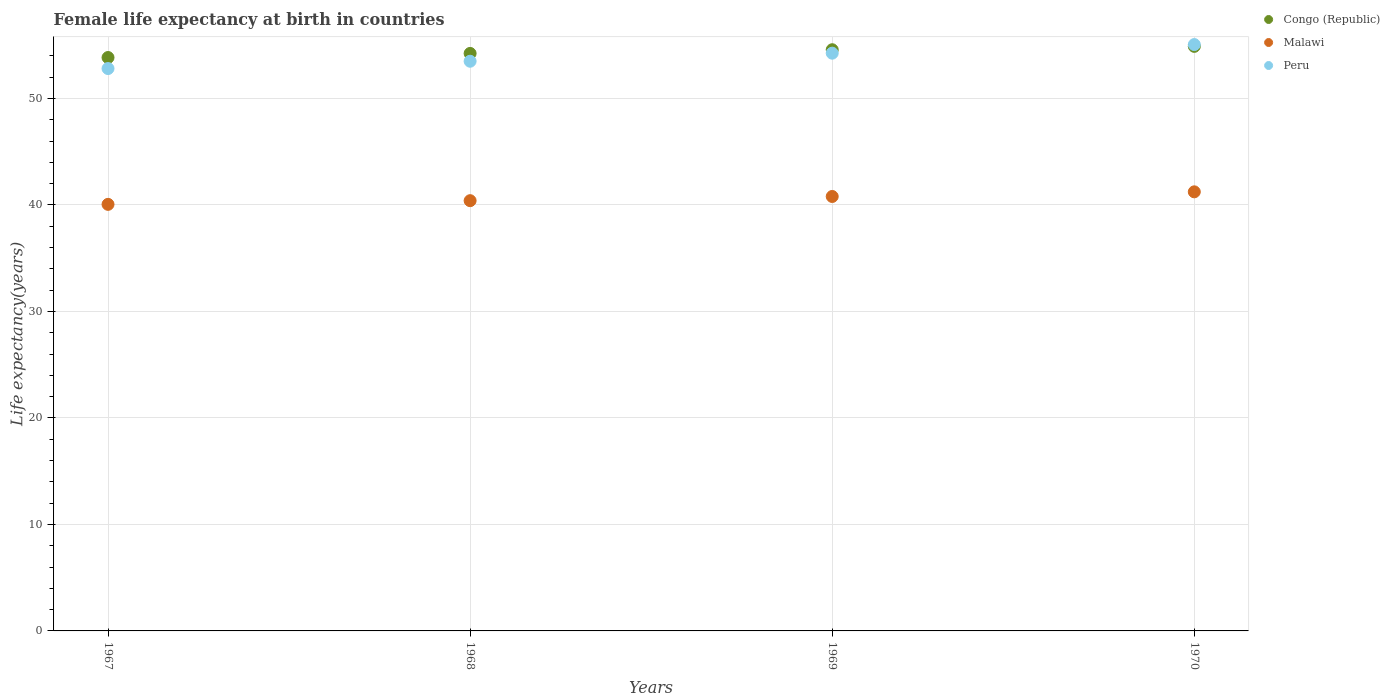What is the female life expectancy at birth in Congo (Republic) in 1969?
Provide a succinct answer. 54.58. Across all years, what is the maximum female life expectancy at birth in Congo (Republic)?
Offer a terse response. 54.89. Across all years, what is the minimum female life expectancy at birth in Peru?
Your answer should be very brief. 52.81. In which year was the female life expectancy at birth in Peru maximum?
Provide a short and direct response. 1970. In which year was the female life expectancy at birth in Congo (Republic) minimum?
Offer a terse response. 1967. What is the total female life expectancy at birth in Congo (Republic) in the graph?
Ensure brevity in your answer.  217.54. What is the difference between the female life expectancy at birth in Congo (Republic) in 1968 and that in 1969?
Provide a short and direct response. -0.35. What is the difference between the female life expectancy at birth in Malawi in 1969 and the female life expectancy at birth in Peru in 1970?
Your answer should be compact. -14.27. What is the average female life expectancy at birth in Malawi per year?
Your response must be concise. 40.62. In the year 1968, what is the difference between the female life expectancy at birth in Peru and female life expectancy at birth in Congo (Republic)?
Your answer should be very brief. -0.73. In how many years, is the female life expectancy at birth in Malawi greater than 42 years?
Provide a short and direct response. 0. What is the ratio of the female life expectancy at birth in Peru in 1969 to that in 1970?
Provide a succinct answer. 0.99. What is the difference between the highest and the second highest female life expectancy at birth in Malawi?
Keep it short and to the point. 0.44. What is the difference between the highest and the lowest female life expectancy at birth in Malawi?
Offer a terse response. 1.18. In how many years, is the female life expectancy at birth in Congo (Republic) greater than the average female life expectancy at birth in Congo (Republic) taken over all years?
Keep it short and to the point. 2. Does the female life expectancy at birth in Peru monotonically increase over the years?
Keep it short and to the point. Yes. Is the female life expectancy at birth in Malawi strictly less than the female life expectancy at birth in Congo (Republic) over the years?
Make the answer very short. Yes. What is the difference between two consecutive major ticks on the Y-axis?
Ensure brevity in your answer.  10. Does the graph contain any zero values?
Your response must be concise. No. Does the graph contain grids?
Keep it short and to the point. Yes. Where does the legend appear in the graph?
Offer a very short reply. Top right. How many legend labels are there?
Provide a short and direct response. 3. What is the title of the graph?
Your answer should be very brief. Female life expectancy at birth in countries. What is the label or title of the Y-axis?
Provide a succinct answer. Life expectancy(years). What is the Life expectancy(years) in Congo (Republic) in 1967?
Your answer should be very brief. 53.84. What is the Life expectancy(years) in Malawi in 1967?
Give a very brief answer. 40.05. What is the Life expectancy(years) in Peru in 1967?
Give a very brief answer. 52.81. What is the Life expectancy(years) in Congo (Republic) in 1968?
Make the answer very short. 54.23. What is the Life expectancy(years) of Malawi in 1968?
Offer a terse response. 40.4. What is the Life expectancy(years) of Peru in 1968?
Your answer should be very brief. 53.49. What is the Life expectancy(years) in Congo (Republic) in 1969?
Provide a short and direct response. 54.58. What is the Life expectancy(years) of Malawi in 1969?
Keep it short and to the point. 40.8. What is the Life expectancy(years) in Peru in 1969?
Provide a short and direct response. 54.25. What is the Life expectancy(years) of Congo (Republic) in 1970?
Offer a terse response. 54.89. What is the Life expectancy(years) in Malawi in 1970?
Provide a short and direct response. 41.23. What is the Life expectancy(years) in Peru in 1970?
Make the answer very short. 55.06. Across all years, what is the maximum Life expectancy(years) in Congo (Republic)?
Ensure brevity in your answer.  54.89. Across all years, what is the maximum Life expectancy(years) of Malawi?
Give a very brief answer. 41.23. Across all years, what is the maximum Life expectancy(years) of Peru?
Keep it short and to the point. 55.06. Across all years, what is the minimum Life expectancy(years) in Congo (Republic)?
Offer a very short reply. 53.84. Across all years, what is the minimum Life expectancy(years) of Malawi?
Offer a very short reply. 40.05. Across all years, what is the minimum Life expectancy(years) of Peru?
Ensure brevity in your answer.  52.81. What is the total Life expectancy(years) in Congo (Republic) in the graph?
Offer a very short reply. 217.54. What is the total Life expectancy(years) in Malawi in the graph?
Your answer should be very brief. 162.48. What is the total Life expectancy(years) of Peru in the graph?
Give a very brief answer. 215.61. What is the difference between the Life expectancy(years) of Congo (Republic) in 1967 and that in 1968?
Provide a short and direct response. -0.39. What is the difference between the Life expectancy(years) in Malawi in 1967 and that in 1968?
Provide a succinct answer. -0.35. What is the difference between the Life expectancy(years) in Peru in 1967 and that in 1968?
Your answer should be very brief. -0.69. What is the difference between the Life expectancy(years) in Congo (Republic) in 1967 and that in 1969?
Provide a short and direct response. -0.73. What is the difference between the Life expectancy(years) of Malawi in 1967 and that in 1969?
Offer a terse response. -0.74. What is the difference between the Life expectancy(years) in Peru in 1967 and that in 1969?
Offer a terse response. -1.44. What is the difference between the Life expectancy(years) of Congo (Republic) in 1967 and that in 1970?
Keep it short and to the point. -1.05. What is the difference between the Life expectancy(years) in Malawi in 1967 and that in 1970?
Keep it short and to the point. -1.18. What is the difference between the Life expectancy(years) of Peru in 1967 and that in 1970?
Your answer should be compact. -2.25. What is the difference between the Life expectancy(years) of Congo (Republic) in 1968 and that in 1969?
Your response must be concise. -0.35. What is the difference between the Life expectancy(years) in Malawi in 1968 and that in 1969?
Provide a succinct answer. -0.39. What is the difference between the Life expectancy(years) in Peru in 1968 and that in 1969?
Ensure brevity in your answer.  -0.76. What is the difference between the Life expectancy(years) in Congo (Republic) in 1968 and that in 1970?
Keep it short and to the point. -0.66. What is the difference between the Life expectancy(years) of Malawi in 1968 and that in 1970?
Offer a terse response. -0.83. What is the difference between the Life expectancy(years) of Peru in 1968 and that in 1970?
Keep it short and to the point. -1.57. What is the difference between the Life expectancy(years) in Congo (Republic) in 1969 and that in 1970?
Offer a terse response. -0.32. What is the difference between the Life expectancy(years) in Malawi in 1969 and that in 1970?
Provide a succinct answer. -0.44. What is the difference between the Life expectancy(years) of Peru in 1969 and that in 1970?
Keep it short and to the point. -0.81. What is the difference between the Life expectancy(years) of Congo (Republic) in 1967 and the Life expectancy(years) of Malawi in 1968?
Give a very brief answer. 13.44. What is the difference between the Life expectancy(years) of Congo (Republic) in 1967 and the Life expectancy(years) of Peru in 1968?
Offer a terse response. 0.35. What is the difference between the Life expectancy(years) of Malawi in 1967 and the Life expectancy(years) of Peru in 1968?
Offer a very short reply. -13.44. What is the difference between the Life expectancy(years) in Congo (Republic) in 1967 and the Life expectancy(years) in Malawi in 1969?
Your response must be concise. 13.05. What is the difference between the Life expectancy(years) in Congo (Republic) in 1967 and the Life expectancy(years) in Peru in 1969?
Provide a succinct answer. -0.41. What is the difference between the Life expectancy(years) of Malawi in 1967 and the Life expectancy(years) of Peru in 1969?
Ensure brevity in your answer.  -14.2. What is the difference between the Life expectancy(years) in Congo (Republic) in 1967 and the Life expectancy(years) in Malawi in 1970?
Ensure brevity in your answer.  12.61. What is the difference between the Life expectancy(years) of Congo (Republic) in 1967 and the Life expectancy(years) of Peru in 1970?
Provide a short and direct response. -1.22. What is the difference between the Life expectancy(years) in Malawi in 1967 and the Life expectancy(years) in Peru in 1970?
Offer a terse response. -15.01. What is the difference between the Life expectancy(years) in Congo (Republic) in 1968 and the Life expectancy(years) in Malawi in 1969?
Your answer should be compact. 13.43. What is the difference between the Life expectancy(years) of Congo (Republic) in 1968 and the Life expectancy(years) of Peru in 1969?
Provide a succinct answer. -0.02. What is the difference between the Life expectancy(years) of Malawi in 1968 and the Life expectancy(years) of Peru in 1969?
Your response must be concise. -13.85. What is the difference between the Life expectancy(years) of Congo (Republic) in 1968 and the Life expectancy(years) of Malawi in 1970?
Make the answer very short. 13. What is the difference between the Life expectancy(years) in Congo (Republic) in 1968 and the Life expectancy(years) in Peru in 1970?
Offer a very short reply. -0.83. What is the difference between the Life expectancy(years) of Malawi in 1968 and the Life expectancy(years) of Peru in 1970?
Offer a very short reply. -14.66. What is the difference between the Life expectancy(years) in Congo (Republic) in 1969 and the Life expectancy(years) in Malawi in 1970?
Keep it short and to the point. 13.34. What is the difference between the Life expectancy(years) in Congo (Republic) in 1969 and the Life expectancy(years) in Peru in 1970?
Your answer should be very brief. -0.48. What is the difference between the Life expectancy(years) in Malawi in 1969 and the Life expectancy(years) in Peru in 1970?
Provide a succinct answer. -14.27. What is the average Life expectancy(years) of Congo (Republic) per year?
Provide a succinct answer. 54.38. What is the average Life expectancy(years) of Malawi per year?
Give a very brief answer. 40.62. What is the average Life expectancy(years) of Peru per year?
Provide a succinct answer. 53.9. In the year 1967, what is the difference between the Life expectancy(years) in Congo (Republic) and Life expectancy(years) in Malawi?
Provide a short and direct response. 13.79. In the year 1967, what is the difference between the Life expectancy(years) of Congo (Republic) and Life expectancy(years) of Peru?
Provide a succinct answer. 1.03. In the year 1967, what is the difference between the Life expectancy(years) in Malawi and Life expectancy(years) in Peru?
Your answer should be very brief. -12.75. In the year 1968, what is the difference between the Life expectancy(years) of Congo (Republic) and Life expectancy(years) of Malawi?
Your answer should be compact. 13.83. In the year 1968, what is the difference between the Life expectancy(years) of Congo (Republic) and Life expectancy(years) of Peru?
Offer a terse response. 0.73. In the year 1968, what is the difference between the Life expectancy(years) in Malawi and Life expectancy(years) in Peru?
Your response must be concise. -13.09. In the year 1969, what is the difference between the Life expectancy(years) in Congo (Republic) and Life expectancy(years) in Malawi?
Provide a short and direct response. 13.78. In the year 1969, what is the difference between the Life expectancy(years) of Congo (Republic) and Life expectancy(years) of Peru?
Provide a succinct answer. 0.32. In the year 1969, what is the difference between the Life expectancy(years) in Malawi and Life expectancy(years) in Peru?
Keep it short and to the point. -13.46. In the year 1970, what is the difference between the Life expectancy(years) in Congo (Republic) and Life expectancy(years) in Malawi?
Ensure brevity in your answer.  13.66. In the year 1970, what is the difference between the Life expectancy(years) in Congo (Republic) and Life expectancy(years) in Peru?
Your answer should be compact. -0.17. In the year 1970, what is the difference between the Life expectancy(years) of Malawi and Life expectancy(years) of Peru?
Offer a terse response. -13.83. What is the ratio of the Life expectancy(years) in Peru in 1967 to that in 1968?
Offer a very short reply. 0.99. What is the ratio of the Life expectancy(years) of Congo (Republic) in 1967 to that in 1969?
Offer a terse response. 0.99. What is the ratio of the Life expectancy(years) of Malawi in 1967 to that in 1969?
Your response must be concise. 0.98. What is the ratio of the Life expectancy(years) of Peru in 1967 to that in 1969?
Your answer should be compact. 0.97. What is the ratio of the Life expectancy(years) in Congo (Republic) in 1967 to that in 1970?
Ensure brevity in your answer.  0.98. What is the ratio of the Life expectancy(years) of Malawi in 1967 to that in 1970?
Give a very brief answer. 0.97. What is the ratio of the Life expectancy(years) of Peru in 1967 to that in 1970?
Make the answer very short. 0.96. What is the ratio of the Life expectancy(years) of Malawi in 1968 to that in 1969?
Your response must be concise. 0.99. What is the ratio of the Life expectancy(years) of Congo (Republic) in 1968 to that in 1970?
Keep it short and to the point. 0.99. What is the ratio of the Life expectancy(years) of Malawi in 1968 to that in 1970?
Offer a very short reply. 0.98. What is the ratio of the Life expectancy(years) of Peru in 1968 to that in 1970?
Give a very brief answer. 0.97. What is the ratio of the Life expectancy(years) in Congo (Republic) in 1969 to that in 1970?
Give a very brief answer. 0.99. What is the ratio of the Life expectancy(years) in Malawi in 1969 to that in 1970?
Your answer should be compact. 0.99. What is the ratio of the Life expectancy(years) of Peru in 1969 to that in 1970?
Your response must be concise. 0.99. What is the difference between the highest and the second highest Life expectancy(years) of Congo (Republic)?
Offer a very short reply. 0.32. What is the difference between the highest and the second highest Life expectancy(years) in Malawi?
Keep it short and to the point. 0.44. What is the difference between the highest and the second highest Life expectancy(years) of Peru?
Keep it short and to the point. 0.81. What is the difference between the highest and the lowest Life expectancy(years) of Congo (Republic)?
Ensure brevity in your answer.  1.05. What is the difference between the highest and the lowest Life expectancy(years) in Malawi?
Offer a terse response. 1.18. What is the difference between the highest and the lowest Life expectancy(years) in Peru?
Your answer should be compact. 2.25. 